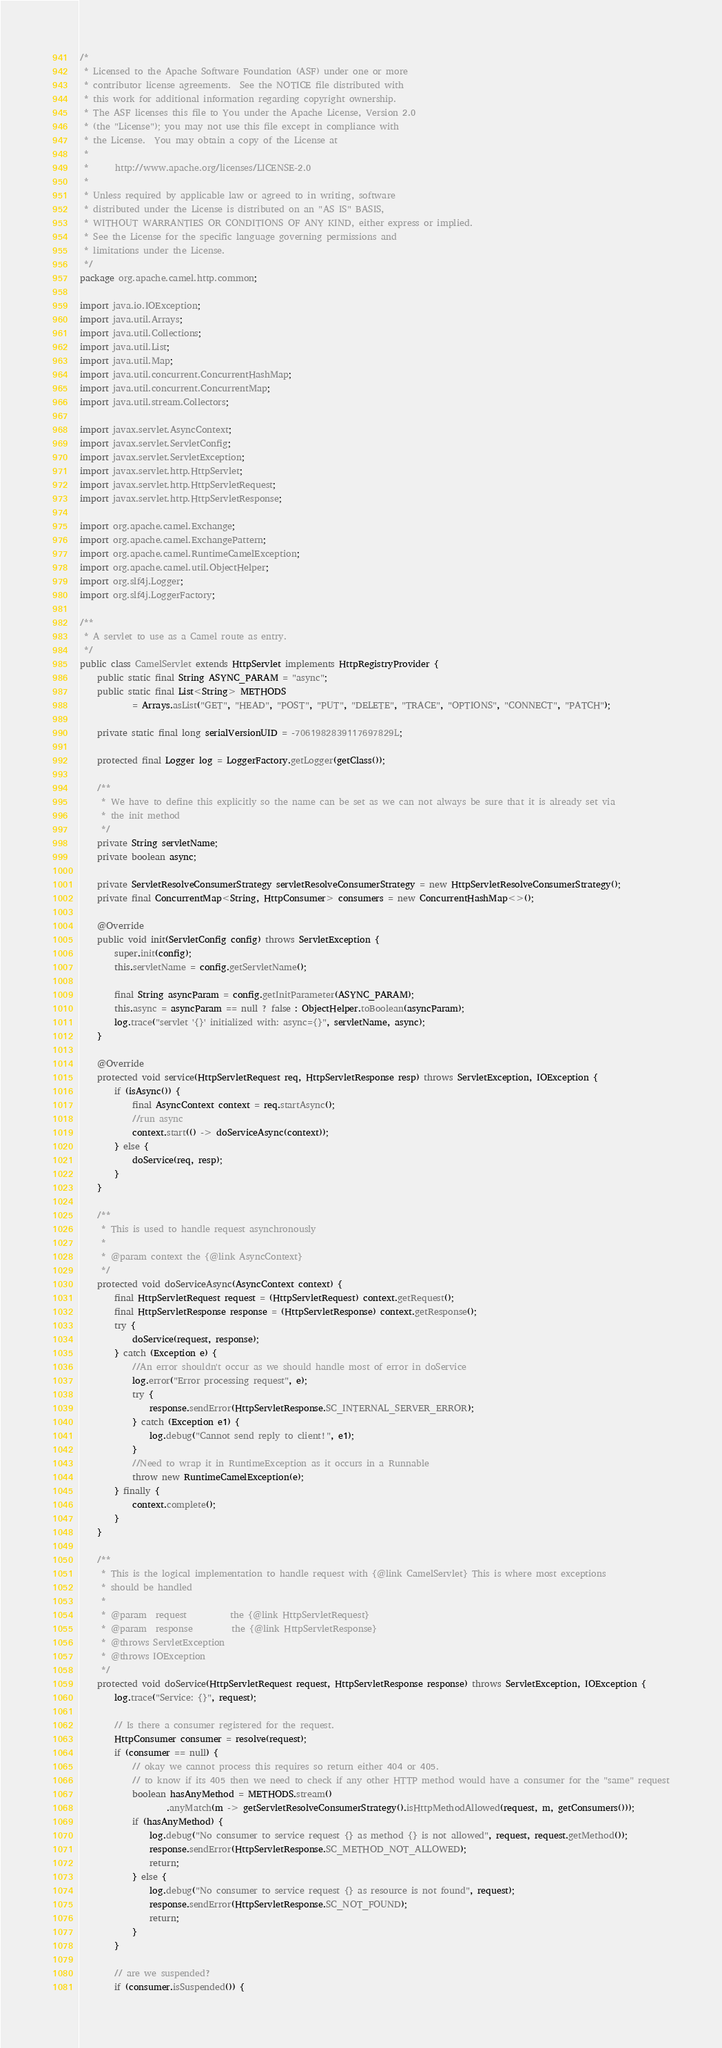Convert code to text. <code><loc_0><loc_0><loc_500><loc_500><_Java_>/*
 * Licensed to the Apache Software Foundation (ASF) under one or more
 * contributor license agreements.  See the NOTICE file distributed with
 * this work for additional information regarding copyright ownership.
 * The ASF licenses this file to You under the Apache License, Version 2.0
 * (the "License"); you may not use this file except in compliance with
 * the License.  You may obtain a copy of the License at
 *
 *      http://www.apache.org/licenses/LICENSE-2.0
 *
 * Unless required by applicable law or agreed to in writing, software
 * distributed under the License is distributed on an "AS IS" BASIS,
 * WITHOUT WARRANTIES OR CONDITIONS OF ANY KIND, either express or implied.
 * See the License for the specific language governing permissions and
 * limitations under the License.
 */
package org.apache.camel.http.common;

import java.io.IOException;
import java.util.Arrays;
import java.util.Collections;
import java.util.List;
import java.util.Map;
import java.util.concurrent.ConcurrentHashMap;
import java.util.concurrent.ConcurrentMap;
import java.util.stream.Collectors;

import javax.servlet.AsyncContext;
import javax.servlet.ServletConfig;
import javax.servlet.ServletException;
import javax.servlet.http.HttpServlet;
import javax.servlet.http.HttpServletRequest;
import javax.servlet.http.HttpServletResponse;

import org.apache.camel.Exchange;
import org.apache.camel.ExchangePattern;
import org.apache.camel.RuntimeCamelException;
import org.apache.camel.util.ObjectHelper;
import org.slf4j.Logger;
import org.slf4j.LoggerFactory;

/**
 * A servlet to use as a Camel route as entry.
 */
public class CamelServlet extends HttpServlet implements HttpRegistryProvider {
    public static final String ASYNC_PARAM = "async";
    public static final List<String> METHODS
            = Arrays.asList("GET", "HEAD", "POST", "PUT", "DELETE", "TRACE", "OPTIONS", "CONNECT", "PATCH");

    private static final long serialVersionUID = -7061982839117697829L;

    protected final Logger log = LoggerFactory.getLogger(getClass());

    /**
     * We have to define this explicitly so the name can be set as we can not always be sure that it is already set via
     * the init method
     */
    private String servletName;
    private boolean async;

    private ServletResolveConsumerStrategy servletResolveConsumerStrategy = new HttpServletResolveConsumerStrategy();
    private final ConcurrentMap<String, HttpConsumer> consumers = new ConcurrentHashMap<>();

    @Override
    public void init(ServletConfig config) throws ServletException {
        super.init(config);
        this.servletName = config.getServletName();

        final String asyncParam = config.getInitParameter(ASYNC_PARAM);
        this.async = asyncParam == null ? false : ObjectHelper.toBoolean(asyncParam);
        log.trace("servlet '{}' initialized with: async={}", servletName, async);
    }

    @Override
    protected void service(HttpServletRequest req, HttpServletResponse resp) throws ServletException, IOException {
        if (isAsync()) {
            final AsyncContext context = req.startAsync();
            //run async
            context.start(() -> doServiceAsync(context));
        } else {
            doService(req, resp);
        }
    }

    /**
     * This is used to handle request asynchronously
     * 
     * @param context the {@link AsyncContext}
     */
    protected void doServiceAsync(AsyncContext context) {
        final HttpServletRequest request = (HttpServletRequest) context.getRequest();
        final HttpServletResponse response = (HttpServletResponse) context.getResponse();
        try {
            doService(request, response);
        } catch (Exception e) {
            //An error shouldn't occur as we should handle most of error in doService
            log.error("Error processing request", e);
            try {
                response.sendError(HttpServletResponse.SC_INTERNAL_SERVER_ERROR);
            } catch (Exception e1) {
                log.debug("Cannot send reply to client!", e1);
            }
            //Need to wrap it in RuntimeException as it occurs in a Runnable
            throw new RuntimeCamelException(e);
        } finally {
            context.complete();
        }
    }

    /**
     * This is the logical implementation to handle request with {@link CamelServlet} This is where most exceptions
     * should be handled
     *
     * @param  request          the {@link HttpServletRequest}
     * @param  response         the {@link HttpServletResponse}
     * @throws ServletException
     * @throws IOException
     */
    protected void doService(HttpServletRequest request, HttpServletResponse response) throws ServletException, IOException {
        log.trace("Service: {}", request);

        // Is there a consumer registered for the request.
        HttpConsumer consumer = resolve(request);
        if (consumer == null) {
            // okay we cannot process this requires so return either 404 or 405.
            // to know if its 405 then we need to check if any other HTTP method would have a consumer for the "same" request
            boolean hasAnyMethod = METHODS.stream()
                    .anyMatch(m -> getServletResolveConsumerStrategy().isHttpMethodAllowed(request, m, getConsumers()));
            if (hasAnyMethod) {
                log.debug("No consumer to service request {} as method {} is not allowed", request, request.getMethod());
                response.sendError(HttpServletResponse.SC_METHOD_NOT_ALLOWED);
                return;
            } else {
                log.debug("No consumer to service request {} as resource is not found", request);
                response.sendError(HttpServletResponse.SC_NOT_FOUND);
                return;
            }
        }

        // are we suspended?
        if (consumer.isSuspended()) {</code> 